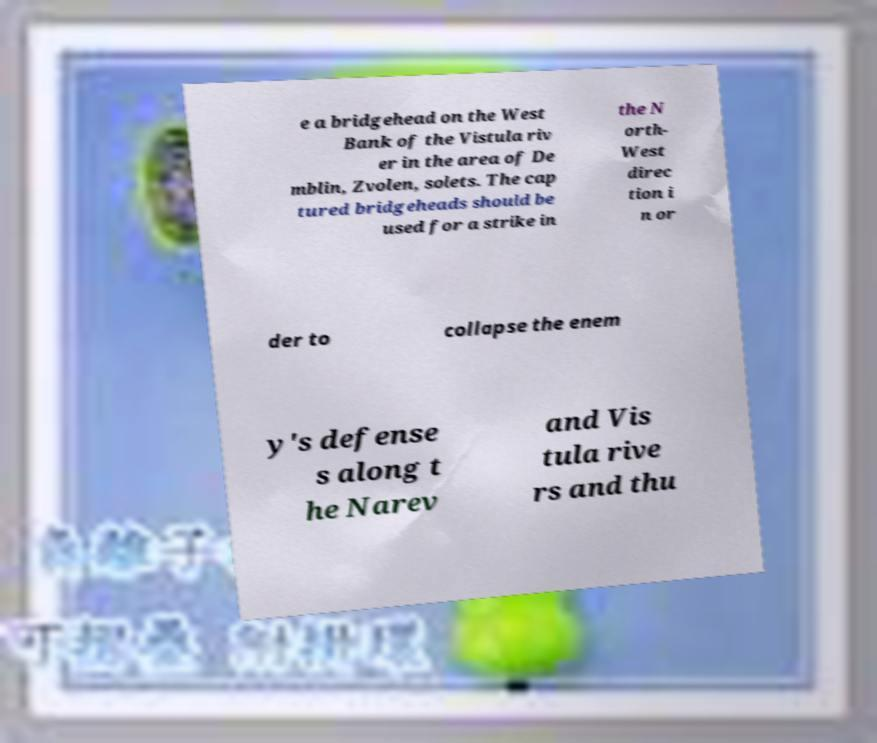Can you accurately transcribe the text from the provided image for me? e a bridgehead on the West Bank of the Vistula riv er in the area of De mblin, Zvolen, solets. The cap tured bridgeheads should be used for a strike in the N orth- West direc tion i n or der to collapse the enem y's defense s along t he Narev and Vis tula rive rs and thu 